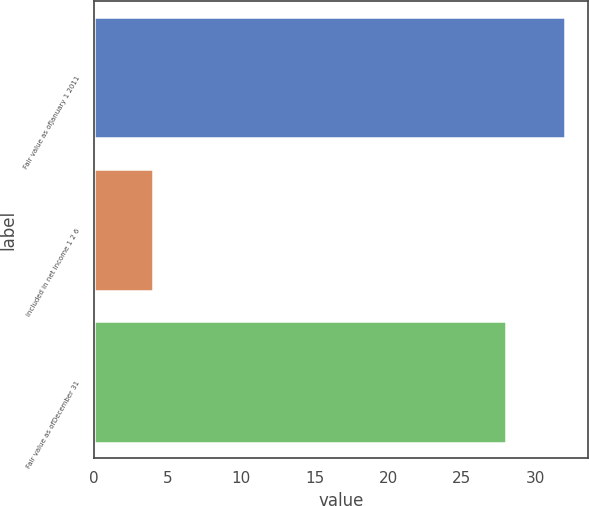<chart> <loc_0><loc_0><loc_500><loc_500><bar_chart><fcel>Fair value as ofJanuary 1 2011<fcel>Included in net income 1 2 6<fcel>Fair value as ofDecember 31<nl><fcel>32<fcel>4<fcel>28<nl></chart> 